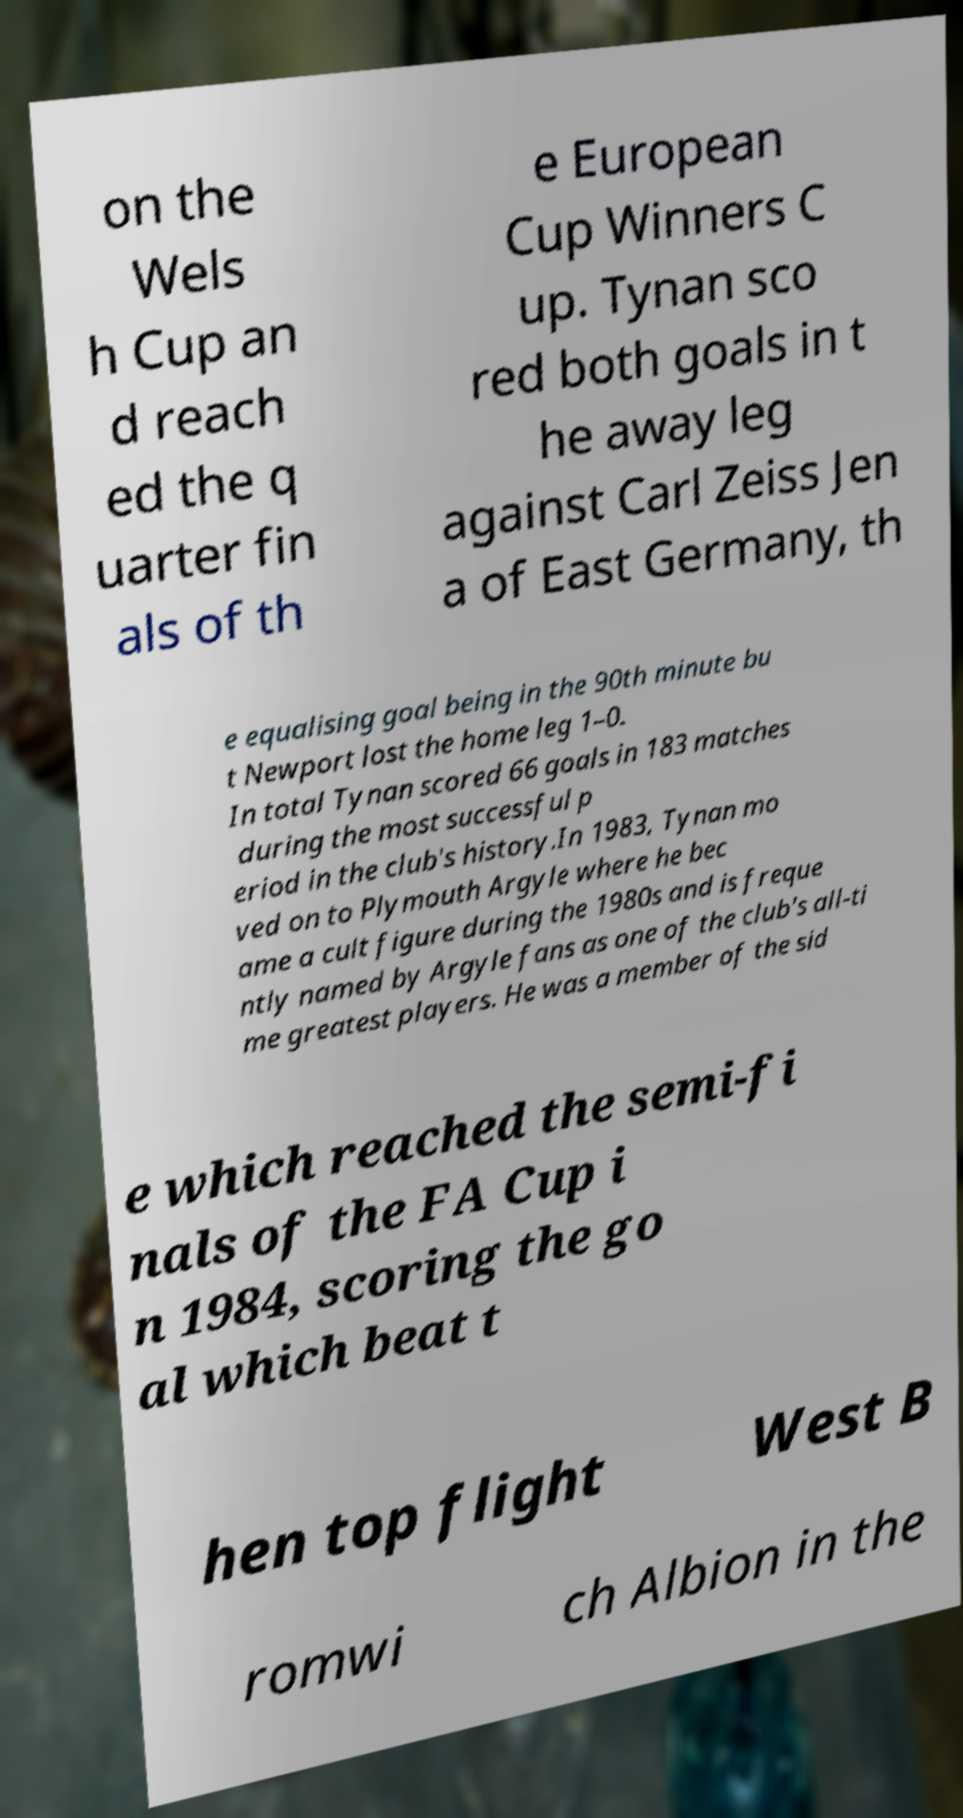Please read and relay the text visible in this image. What does it say? on the Wels h Cup an d reach ed the q uarter fin als of th e European Cup Winners C up. Tynan sco red both goals in t he away leg against Carl Zeiss Jen a of East Germany, th e equalising goal being in the 90th minute bu t Newport lost the home leg 1–0. In total Tynan scored 66 goals in 183 matches during the most successful p eriod in the club's history.In 1983, Tynan mo ved on to Plymouth Argyle where he bec ame a cult figure during the 1980s and is freque ntly named by Argyle fans as one of the club's all-ti me greatest players. He was a member of the sid e which reached the semi-fi nals of the FA Cup i n 1984, scoring the go al which beat t hen top flight West B romwi ch Albion in the 